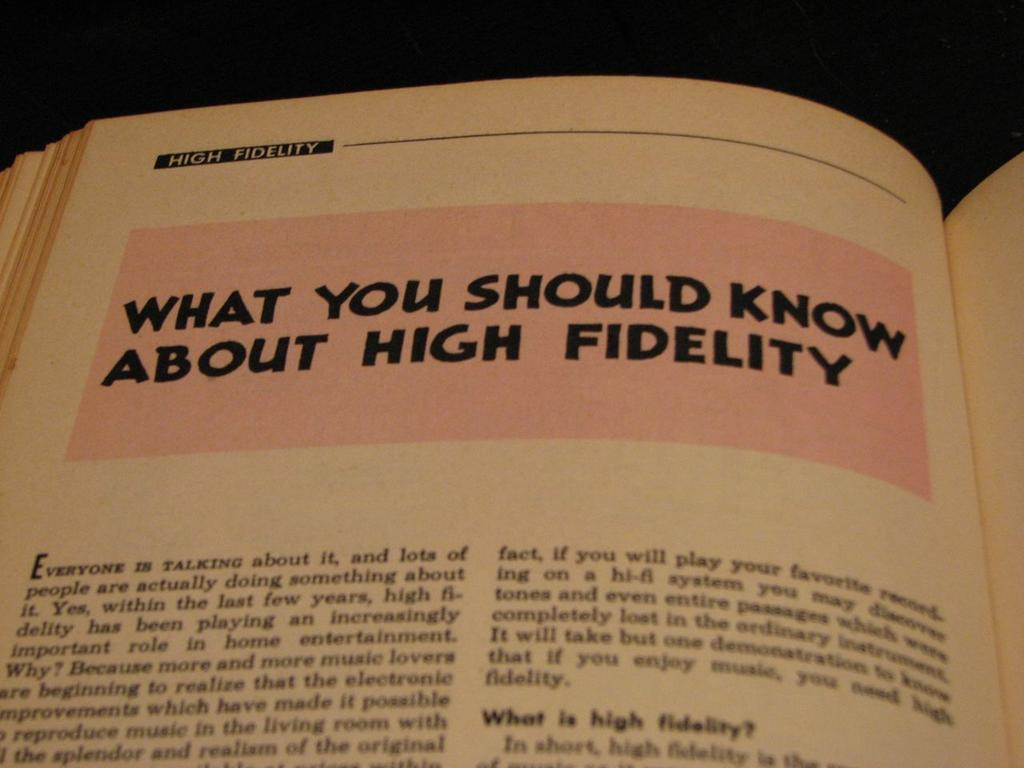Provide a one-sentence caption for the provided image. The chapter is titled What you Should Know about High Fidelity. 